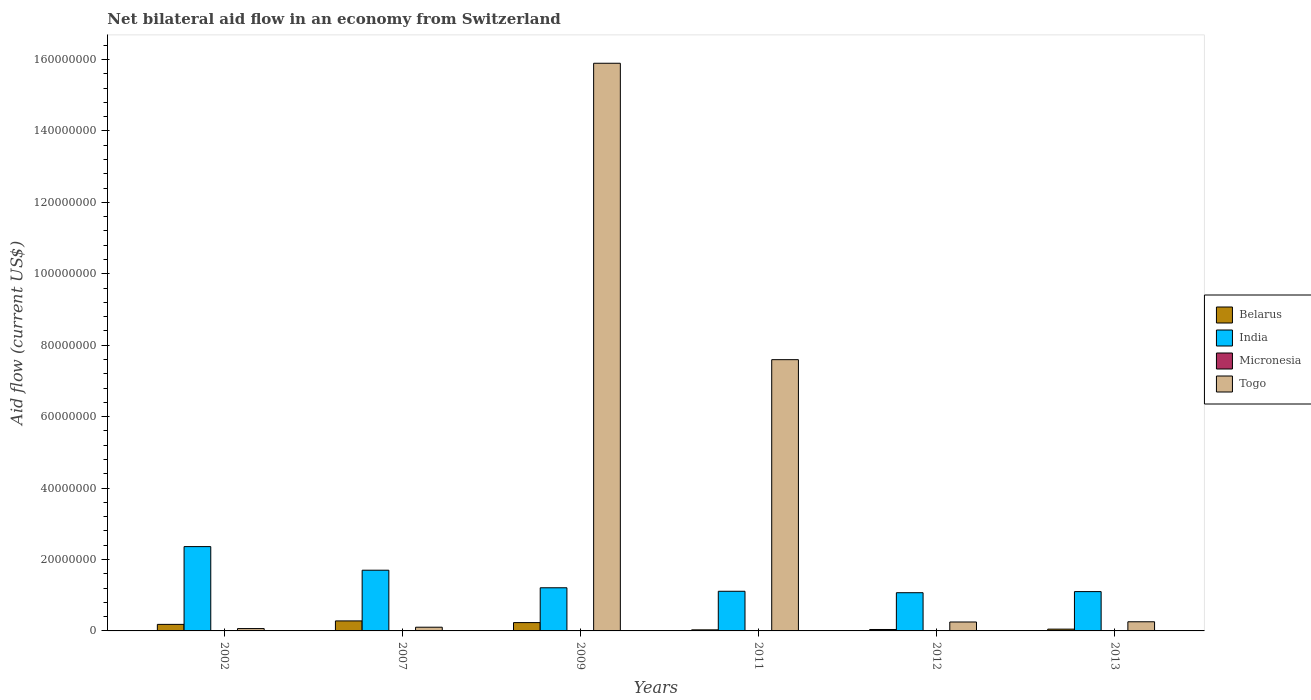How many different coloured bars are there?
Provide a succinct answer. 4. How many groups of bars are there?
Make the answer very short. 6. Are the number of bars on each tick of the X-axis equal?
Provide a succinct answer. Yes. What is the label of the 4th group of bars from the left?
Give a very brief answer. 2011. What is the net bilateral aid flow in Togo in 2007?
Ensure brevity in your answer.  1.04e+06. Across all years, what is the maximum net bilateral aid flow in Belarus?
Keep it short and to the point. 2.80e+06. In which year was the net bilateral aid flow in Togo minimum?
Your answer should be compact. 2002. What is the total net bilateral aid flow in Togo in the graph?
Make the answer very short. 2.42e+08. What is the difference between the net bilateral aid flow in Togo in 2009 and that in 2013?
Make the answer very short. 1.56e+08. What is the difference between the net bilateral aid flow in Micronesia in 2009 and the net bilateral aid flow in India in 2013?
Ensure brevity in your answer.  -1.10e+07. What is the average net bilateral aid flow in Belarus per year?
Keep it short and to the point. 1.36e+06. In the year 2007, what is the difference between the net bilateral aid flow in Micronesia and net bilateral aid flow in Belarus?
Ensure brevity in your answer.  -2.75e+06. In how many years, is the net bilateral aid flow in Belarus greater than 32000000 US$?
Provide a short and direct response. 0. What is the ratio of the net bilateral aid flow in Togo in 2002 to that in 2011?
Make the answer very short. 0.01. What is the difference between the highest and the second highest net bilateral aid flow in Togo?
Keep it short and to the point. 8.30e+07. What is the difference between the highest and the lowest net bilateral aid flow in Togo?
Ensure brevity in your answer.  1.58e+08. In how many years, is the net bilateral aid flow in India greater than the average net bilateral aid flow in India taken over all years?
Your response must be concise. 2. Is the sum of the net bilateral aid flow in Micronesia in 2002 and 2013 greater than the maximum net bilateral aid flow in Belarus across all years?
Give a very brief answer. No. What does the 3rd bar from the left in 2012 represents?
Offer a terse response. Micronesia. Are the values on the major ticks of Y-axis written in scientific E-notation?
Make the answer very short. No. Does the graph contain grids?
Offer a very short reply. No. What is the title of the graph?
Provide a succinct answer. Net bilateral aid flow in an economy from Switzerland. Does "Dominica" appear as one of the legend labels in the graph?
Offer a terse response. No. What is the label or title of the Y-axis?
Ensure brevity in your answer.  Aid flow (current US$). What is the Aid flow (current US$) in Belarus in 2002?
Give a very brief answer. 1.83e+06. What is the Aid flow (current US$) in India in 2002?
Keep it short and to the point. 2.36e+07. What is the Aid flow (current US$) of Togo in 2002?
Your answer should be very brief. 6.60e+05. What is the Aid flow (current US$) in Belarus in 2007?
Keep it short and to the point. 2.80e+06. What is the Aid flow (current US$) of India in 2007?
Keep it short and to the point. 1.70e+07. What is the Aid flow (current US$) of Micronesia in 2007?
Make the answer very short. 5.00e+04. What is the Aid flow (current US$) of Togo in 2007?
Provide a succinct answer. 1.04e+06. What is the Aid flow (current US$) in Belarus in 2009?
Offer a terse response. 2.33e+06. What is the Aid flow (current US$) in India in 2009?
Give a very brief answer. 1.21e+07. What is the Aid flow (current US$) in Togo in 2009?
Offer a terse response. 1.59e+08. What is the Aid flow (current US$) in Belarus in 2011?
Keep it short and to the point. 3.00e+05. What is the Aid flow (current US$) of India in 2011?
Make the answer very short. 1.11e+07. What is the Aid flow (current US$) of Micronesia in 2011?
Your response must be concise. 3.00e+04. What is the Aid flow (current US$) of Togo in 2011?
Your response must be concise. 7.60e+07. What is the Aid flow (current US$) of India in 2012?
Provide a succinct answer. 1.07e+07. What is the Aid flow (current US$) of Micronesia in 2012?
Your response must be concise. 2.00e+04. What is the Aid flow (current US$) of Togo in 2012?
Your response must be concise. 2.50e+06. What is the Aid flow (current US$) in India in 2013?
Offer a terse response. 1.10e+07. What is the Aid flow (current US$) of Togo in 2013?
Offer a very short reply. 2.56e+06. Across all years, what is the maximum Aid flow (current US$) in Belarus?
Offer a very short reply. 2.80e+06. Across all years, what is the maximum Aid flow (current US$) in India?
Offer a terse response. 2.36e+07. Across all years, what is the maximum Aid flow (current US$) of Togo?
Provide a succinct answer. 1.59e+08. Across all years, what is the minimum Aid flow (current US$) in India?
Provide a short and direct response. 1.07e+07. What is the total Aid flow (current US$) of Belarus in the graph?
Your answer should be very brief. 8.16e+06. What is the total Aid flow (current US$) of India in the graph?
Provide a succinct answer. 8.55e+07. What is the total Aid flow (current US$) of Togo in the graph?
Keep it short and to the point. 2.42e+08. What is the difference between the Aid flow (current US$) of Belarus in 2002 and that in 2007?
Your answer should be very brief. -9.70e+05. What is the difference between the Aid flow (current US$) of India in 2002 and that in 2007?
Your answer should be compact. 6.61e+06. What is the difference between the Aid flow (current US$) of Micronesia in 2002 and that in 2007?
Give a very brief answer. -10000. What is the difference between the Aid flow (current US$) of Togo in 2002 and that in 2007?
Keep it short and to the point. -3.80e+05. What is the difference between the Aid flow (current US$) of Belarus in 2002 and that in 2009?
Ensure brevity in your answer.  -5.00e+05. What is the difference between the Aid flow (current US$) of India in 2002 and that in 2009?
Make the answer very short. 1.15e+07. What is the difference between the Aid flow (current US$) in Micronesia in 2002 and that in 2009?
Provide a succinct answer. 10000. What is the difference between the Aid flow (current US$) of Togo in 2002 and that in 2009?
Give a very brief answer. -1.58e+08. What is the difference between the Aid flow (current US$) in Belarus in 2002 and that in 2011?
Offer a terse response. 1.53e+06. What is the difference between the Aid flow (current US$) in India in 2002 and that in 2011?
Offer a terse response. 1.25e+07. What is the difference between the Aid flow (current US$) of Togo in 2002 and that in 2011?
Offer a terse response. -7.53e+07. What is the difference between the Aid flow (current US$) in Belarus in 2002 and that in 2012?
Give a very brief answer. 1.43e+06. What is the difference between the Aid flow (current US$) in India in 2002 and that in 2012?
Your answer should be compact. 1.29e+07. What is the difference between the Aid flow (current US$) in Togo in 2002 and that in 2012?
Your response must be concise. -1.84e+06. What is the difference between the Aid flow (current US$) in Belarus in 2002 and that in 2013?
Give a very brief answer. 1.33e+06. What is the difference between the Aid flow (current US$) in India in 2002 and that in 2013?
Give a very brief answer. 1.26e+07. What is the difference between the Aid flow (current US$) of Togo in 2002 and that in 2013?
Give a very brief answer. -1.90e+06. What is the difference between the Aid flow (current US$) in Belarus in 2007 and that in 2009?
Offer a very short reply. 4.70e+05. What is the difference between the Aid flow (current US$) in India in 2007 and that in 2009?
Keep it short and to the point. 4.92e+06. What is the difference between the Aid flow (current US$) of Micronesia in 2007 and that in 2009?
Your answer should be very brief. 2.00e+04. What is the difference between the Aid flow (current US$) of Togo in 2007 and that in 2009?
Offer a terse response. -1.58e+08. What is the difference between the Aid flow (current US$) in Belarus in 2007 and that in 2011?
Your answer should be compact. 2.50e+06. What is the difference between the Aid flow (current US$) in India in 2007 and that in 2011?
Offer a terse response. 5.90e+06. What is the difference between the Aid flow (current US$) of Micronesia in 2007 and that in 2011?
Give a very brief answer. 2.00e+04. What is the difference between the Aid flow (current US$) in Togo in 2007 and that in 2011?
Provide a short and direct response. -7.49e+07. What is the difference between the Aid flow (current US$) of Belarus in 2007 and that in 2012?
Provide a short and direct response. 2.40e+06. What is the difference between the Aid flow (current US$) in India in 2007 and that in 2012?
Ensure brevity in your answer.  6.30e+06. What is the difference between the Aid flow (current US$) of Togo in 2007 and that in 2012?
Ensure brevity in your answer.  -1.46e+06. What is the difference between the Aid flow (current US$) in Belarus in 2007 and that in 2013?
Provide a short and direct response. 2.30e+06. What is the difference between the Aid flow (current US$) in India in 2007 and that in 2013?
Ensure brevity in your answer.  5.99e+06. What is the difference between the Aid flow (current US$) in Micronesia in 2007 and that in 2013?
Provide a succinct answer. 2.00e+04. What is the difference between the Aid flow (current US$) of Togo in 2007 and that in 2013?
Ensure brevity in your answer.  -1.52e+06. What is the difference between the Aid flow (current US$) of Belarus in 2009 and that in 2011?
Provide a short and direct response. 2.03e+06. What is the difference between the Aid flow (current US$) in India in 2009 and that in 2011?
Offer a terse response. 9.80e+05. What is the difference between the Aid flow (current US$) of Togo in 2009 and that in 2011?
Your answer should be compact. 8.30e+07. What is the difference between the Aid flow (current US$) of Belarus in 2009 and that in 2012?
Keep it short and to the point. 1.93e+06. What is the difference between the Aid flow (current US$) in India in 2009 and that in 2012?
Give a very brief answer. 1.38e+06. What is the difference between the Aid flow (current US$) in Micronesia in 2009 and that in 2012?
Offer a very short reply. 10000. What is the difference between the Aid flow (current US$) of Togo in 2009 and that in 2012?
Offer a terse response. 1.56e+08. What is the difference between the Aid flow (current US$) in Belarus in 2009 and that in 2013?
Provide a short and direct response. 1.83e+06. What is the difference between the Aid flow (current US$) of India in 2009 and that in 2013?
Provide a short and direct response. 1.07e+06. What is the difference between the Aid flow (current US$) of Togo in 2009 and that in 2013?
Keep it short and to the point. 1.56e+08. What is the difference between the Aid flow (current US$) of Belarus in 2011 and that in 2012?
Offer a terse response. -1.00e+05. What is the difference between the Aid flow (current US$) of India in 2011 and that in 2012?
Your response must be concise. 4.00e+05. What is the difference between the Aid flow (current US$) of Togo in 2011 and that in 2012?
Provide a succinct answer. 7.34e+07. What is the difference between the Aid flow (current US$) in Micronesia in 2011 and that in 2013?
Your answer should be compact. 0. What is the difference between the Aid flow (current US$) of Togo in 2011 and that in 2013?
Your answer should be compact. 7.34e+07. What is the difference between the Aid flow (current US$) in India in 2012 and that in 2013?
Your answer should be very brief. -3.10e+05. What is the difference between the Aid flow (current US$) of Micronesia in 2012 and that in 2013?
Provide a succinct answer. -10000. What is the difference between the Aid flow (current US$) of Belarus in 2002 and the Aid flow (current US$) of India in 2007?
Give a very brief answer. -1.52e+07. What is the difference between the Aid flow (current US$) of Belarus in 2002 and the Aid flow (current US$) of Micronesia in 2007?
Provide a short and direct response. 1.78e+06. What is the difference between the Aid flow (current US$) of Belarus in 2002 and the Aid flow (current US$) of Togo in 2007?
Ensure brevity in your answer.  7.90e+05. What is the difference between the Aid flow (current US$) of India in 2002 and the Aid flow (current US$) of Micronesia in 2007?
Make the answer very short. 2.36e+07. What is the difference between the Aid flow (current US$) in India in 2002 and the Aid flow (current US$) in Togo in 2007?
Your response must be concise. 2.26e+07. What is the difference between the Aid flow (current US$) in Belarus in 2002 and the Aid flow (current US$) in India in 2009?
Provide a short and direct response. -1.02e+07. What is the difference between the Aid flow (current US$) of Belarus in 2002 and the Aid flow (current US$) of Micronesia in 2009?
Your response must be concise. 1.80e+06. What is the difference between the Aid flow (current US$) in Belarus in 2002 and the Aid flow (current US$) in Togo in 2009?
Ensure brevity in your answer.  -1.57e+08. What is the difference between the Aid flow (current US$) of India in 2002 and the Aid flow (current US$) of Micronesia in 2009?
Your answer should be very brief. 2.36e+07. What is the difference between the Aid flow (current US$) of India in 2002 and the Aid flow (current US$) of Togo in 2009?
Ensure brevity in your answer.  -1.35e+08. What is the difference between the Aid flow (current US$) in Micronesia in 2002 and the Aid flow (current US$) in Togo in 2009?
Your answer should be compact. -1.59e+08. What is the difference between the Aid flow (current US$) of Belarus in 2002 and the Aid flow (current US$) of India in 2011?
Provide a succinct answer. -9.27e+06. What is the difference between the Aid flow (current US$) in Belarus in 2002 and the Aid flow (current US$) in Micronesia in 2011?
Your answer should be very brief. 1.80e+06. What is the difference between the Aid flow (current US$) of Belarus in 2002 and the Aid flow (current US$) of Togo in 2011?
Provide a succinct answer. -7.41e+07. What is the difference between the Aid flow (current US$) in India in 2002 and the Aid flow (current US$) in Micronesia in 2011?
Offer a very short reply. 2.36e+07. What is the difference between the Aid flow (current US$) in India in 2002 and the Aid flow (current US$) in Togo in 2011?
Provide a short and direct response. -5.23e+07. What is the difference between the Aid flow (current US$) in Micronesia in 2002 and the Aid flow (current US$) in Togo in 2011?
Ensure brevity in your answer.  -7.59e+07. What is the difference between the Aid flow (current US$) in Belarus in 2002 and the Aid flow (current US$) in India in 2012?
Provide a short and direct response. -8.87e+06. What is the difference between the Aid flow (current US$) in Belarus in 2002 and the Aid flow (current US$) in Micronesia in 2012?
Ensure brevity in your answer.  1.81e+06. What is the difference between the Aid flow (current US$) of Belarus in 2002 and the Aid flow (current US$) of Togo in 2012?
Your answer should be very brief. -6.70e+05. What is the difference between the Aid flow (current US$) of India in 2002 and the Aid flow (current US$) of Micronesia in 2012?
Your answer should be compact. 2.36e+07. What is the difference between the Aid flow (current US$) in India in 2002 and the Aid flow (current US$) in Togo in 2012?
Your response must be concise. 2.11e+07. What is the difference between the Aid flow (current US$) in Micronesia in 2002 and the Aid flow (current US$) in Togo in 2012?
Keep it short and to the point. -2.46e+06. What is the difference between the Aid flow (current US$) in Belarus in 2002 and the Aid flow (current US$) in India in 2013?
Keep it short and to the point. -9.18e+06. What is the difference between the Aid flow (current US$) in Belarus in 2002 and the Aid flow (current US$) in Micronesia in 2013?
Your answer should be compact. 1.80e+06. What is the difference between the Aid flow (current US$) in Belarus in 2002 and the Aid flow (current US$) in Togo in 2013?
Your response must be concise. -7.30e+05. What is the difference between the Aid flow (current US$) of India in 2002 and the Aid flow (current US$) of Micronesia in 2013?
Ensure brevity in your answer.  2.36e+07. What is the difference between the Aid flow (current US$) of India in 2002 and the Aid flow (current US$) of Togo in 2013?
Offer a terse response. 2.10e+07. What is the difference between the Aid flow (current US$) in Micronesia in 2002 and the Aid flow (current US$) in Togo in 2013?
Offer a terse response. -2.52e+06. What is the difference between the Aid flow (current US$) of Belarus in 2007 and the Aid flow (current US$) of India in 2009?
Your answer should be very brief. -9.28e+06. What is the difference between the Aid flow (current US$) of Belarus in 2007 and the Aid flow (current US$) of Micronesia in 2009?
Offer a terse response. 2.77e+06. What is the difference between the Aid flow (current US$) in Belarus in 2007 and the Aid flow (current US$) in Togo in 2009?
Provide a succinct answer. -1.56e+08. What is the difference between the Aid flow (current US$) of India in 2007 and the Aid flow (current US$) of Micronesia in 2009?
Make the answer very short. 1.70e+07. What is the difference between the Aid flow (current US$) in India in 2007 and the Aid flow (current US$) in Togo in 2009?
Offer a terse response. -1.42e+08. What is the difference between the Aid flow (current US$) of Micronesia in 2007 and the Aid flow (current US$) of Togo in 2009?
Offer a terse response. -1.59e+08. What is the difference between the Aid flow (current US$) in Belarus in 2007 and the Aid flow (current US$) in India in 2011?
Ensure brevity in your answer.  -8.30e+06. What is the difference between the Aid flow (current US$) of Belarus in 2007 and the Aid flow (current US$) of Micronesia in 2011?
Provide a short and direct response. 2.77e+06. What is the difference between the Aid flow (current US$) of Belarus in 2007 and the Aid flow (current US$) of Togo in 2011?
Give a very brief answer. -7.32e+07. What is the difference between the Aid flow (current US$) of India in 2007 and the Aid flow (current US$) of Micronesia in 2011?
Keep it short and to the point. 1.70e+07. What is the difference between the Aid flow (current US$) of India in 2007 and the Aid flow (current US$) of Togo in 2011?
Make the answer very short. -5.90e+07. What is the difference between the Aid flow (current US$) of Micronesia in 2007 and the Aid flow (current US$) of Togo in 2011?
Offer a very short reply. -7.59e+07. What is the difference between the Aid flow (current US$) of Belarus in 2007 and the Aid flow (current US$) of India in 2012?
Offer a very short reply. -7.90e+06. What is the difference between the Aid flow (current US$) in Belarus in 2007 and the Aid flow (current US$) in Micronesia in 2012?
Make the answer very short. 2.78e+06. What is the difference between the Aid flow (current US$) of India in 2007 and the Aid flow (current US$) of Micronesia in 2012?
Your answer should be compact. 1.70e+07. What is the difference between the Aid flow (current US$) of India in 2007 and the Aid flow (current US$) of Togo in 2012?
Provide a succinct answer. 1.45e+07. What is the difference between the Aid flow (current US$) in Micronesia in 2007 and the Aid flow (current US$) in Togo in 2012?
Offer a very short reply. -2.45e+06. What is the difference between the Aid flow (current US$) of Belarus in 2007 and the Aid flow (current US$) of India in 2013?
Your response must be concise. -8.21e+06. What is the difference between the Aid flow (current US$) of Belarus in 2007 and the Aid flow (current US$) of Micronesia in 2013?
Keep it short and to the point. 2.77e+06. What is the difference between the Aid flow (current US$) of India in 2007 and the Aid flow (current US$) of Micronesia in 2013?
Make the answer very short. 1.70e+07. What is the difference between the Aid flow (current US$) in India in 2007 and the Aid flow (current US$) in Togo in 2013?
Ensure brevity in your answer.  1.44e+07. What is the difference between the Aid flow (current US$) in Micronesia in 2007 and the Aid flow (current US$) in Togo in 2013?
Offer a very short reply. -2.51e+06. What is the difference between the Aid flow (current US$) of Belarus in 2009 and the Aid flow (current US$) of India in 2011?
Give a very brief answer. -8.77e+06. What is the difference between the Aid flow (current US$) in Belarus in 2009 and the Aid flow (current US$) in Micronesia in 2011?
Offer a terse response. 2.30e+06. What is the difference between the Aid flow (current US$) of Belarus in 2009 and the Aid flow (current US$) of Togo in 2011?
Provide a short and direct response. -7.36e+07. What is the difference between the Aid flow (current US$) of India in 2009 and the Aid flow (current US$) of Micronesia in 2011?
Offer a very short reply. 1.20e+07. What is the difference between the Aid flow (current US$) of India in 2009 and the Aid flow (current US$) of Togo in 2011?
Your answer should be compact. -6.39e+07. What is the difference between the Aid flow (current US$) in Micronesia in 2009 and the Aid flow (current US$) in Togo in 2011?
Provide a short and direct response. -7.59e+07. What is the difference between the Aid flow (current US$) of Belarus in 2009 and the Aid flow (current US$) of India in 2012?
Give a very brief answer. -8.37e+06. What is the difference between the Aid flow (current US$) of Belarus in 2009 and the Aid flow (current US$) of Micronesia in 2012?
Your answer should be compact. 2.31e+06. What is the difference between the Aid flow (current US$) of India in 2009 and the Aid flow (current US$) of Micronesia in 2012?
Your answer should be very brief. 1.21e+07. What is the difference between the Aid flow (current US$) in India in 2009 and the Aid flow (current US$) in Togo in 2012?
Provide a succinct answer. 9.58e+06. What is the difference between the Aid flow (current US$) in Micronesia in 2009 and the Aid flow (current US$) in Togo in 2012?
Your answer should be very brief. -2.47e+06. What is the difference between the Aid flow (current US$) in Belarus in 2009 and the Aid flow (current US$) in India in 2013?
Provide a succinct answer. -8.68e+06. What is the difference between the Aid flow (current US$) of Belarus in 2009 and the Aid flow (current US$) of Micronesia in 2013?
Offer a very short reply. 2.30e+06. What is the difference between the Aid flow (current US$) of Belarus in 2009 and the Aid flow (current US$) of Togo in 2013?
Give a very brief answer. -2.30e+05. What is the difference between the Aid flow (current US$) in India in 2009 and the Aid flow (current US$) in Micronesia in 2013?
Your answer should be very brief. 1.20e+07. What is the difference between the Aid flow (current US$) in India in 2009 and the Aid flow (current US$) in Togo in 2013?
Make the answer very short. 9.52e+06. What is the difference between the Aid flow (current US$) of Micronesia in 2009 and the Aid flow (current US$) of Togo in 2013?
Make the answer very short. -2.53e+06. What is the difference between the Aid flow (current US$) in Belarus in 2011 and the Aid flow (current US$) in India in 2012?
Your response must be concise. -1.04e+07. What is the difference between the Aid flow (current US$) in Belarus in 2011 and the Aid flow (current US$) in Micronesia in 2012?
Keep it short and to the point. 2.80e+05. What is the difference between the Aid flow (current US$) of Belarus in 2011 and the Aid flow (current US$) of Togo in 2012?
Your answer should be compact. -2.20e+06. What is the difference between the Aid flow (current US$) in India in 2011 and the Aid flow (current US$) in Micronesia in 2012?
Provide a succinct answer. 1.11e+07. What is the difference between the Aid flow (current US$) in India in 2011 and the Aid flow (current US$) in Togo in 2012?
Give a very brief answer. 8.60e+06. What is the difference between the Aid flow (current US$) in Micronesia in 2011 and the Aid flow (current US$) in Togo in 2012?
Keep it short and to the point. -2.47e+06. What is the difference between the Aid flow (current US$) of Belarus in 2011 and the Aid flow (current US$) of India in 2013?
Offer a very short reply. -1.07e+07. What is the difference between the Aid flow (current US$) of Belarus in 2011 and the Aid flow (current US$) of Togo in 2013?
Make the answer very short. -2.26e+06. What is the difference between the Aid flow (current US$) in India in 2011 and the Aid flow (current US$) in Micronesia in 2013?
Your answer should be compact. 1.11e+07. What is the difference between the Aid flow (current US$) of India in 2011 and the Aid flow (current US$) of Togo in 2013?
Offer a very short reply. 8.54e+06. What is the difference between the Aid flow (current US$) in Micronesia in 2011 and the Aid flow (current US$) in Togo in 2013?
Your answer should be very brief. -2.53e+06. What is the difference between the Aid flow (current US$) of Belarus in 2012 and the Aid flow (current US$) of India in 2013?
Your response must be concise. -1.06e+07. What is the difference between the Aid flow (current US$) of Belarus in 2012 and the Aid flow (current US$) of Togo in 2013?
Ensure brevity in your answer.  -2.16e+06. What is the difference between the Aid flow (current US$) of India in 2012 and the Aid flow (current US$) of Micronesia in 2013?
Offer a very short reply. 1.07e+07. What is the difference between the Aid flow (current US$) in India in 2012 and the Aid flow (current US$) in Togo in 2013?
Your answer should be compact. 8.14e+06. What is the difference between the Aid flow (current US$) in Micronesia in 2012 and the Aid flow (current US$) in Togo in 2013?
Provide a short and direct response. -2.54e+06. What is the average Aid flow (current US$) in Belarus per year?
Provide a succinct answer. 1.36e+06. What is the average Aid flow (current US$) in India per year?
Give a very brief answer. 1.42e+07. What is the average Aid flow (current US$) in Micronesia per year?
Your response must be concise. 3.33e+04. What is the average Aid flow (current US$) of Togo per year?
Offer a very short reply. 4.03e+07. In the year 2002, what is the difference between the Aid flow (current US$) of Belarus and Aid flow (current US$) of India?
Provide a succinct answer. -2.18e+07. In the year 2002, what is the difference between the Aid flow (current US$) in Belarus and Aid flow (current US$) in Micronesia?
Offer a very short reply. 1.79e+06. In the year 2002, what is the difference between the Aid flow (current US$) in Belarus and Aid flow (current US$) in Togo?
Provide a succinct answer. 1.17e+06. In the year 2002, what is the difference between the Aid flow (current US$) in India and Aid flow (current US$) in Micronesia?
Your answer should be compact. 2.36e+07. In the year 2002, what is the difference between the Aid flow (current US$) in India and Aid flow (current US$) in Togo?
Give a very brief answer. 2.30e+07. In the year 2002, what is the difference between the Aid flow (current US$) of Micronesia and Aid flow (current US$) of Togo?
Your response must be concise. -6.20e+05. In the year 2007, what is the difference between the Aid flow (current US$) of Belarus and Aid flow (current US$) of India?
Your answer should be very brief. -1.42e+07. In the year 2007, what is the difference between the Aid flow (current US$) in Belarus and Aid flow (current US$) in Micronesia?
Keep it short and to the point. 2.75e+06. In the year 2007, what is the difference between the Aid flow (current US$) in Belarus and Aid flow (current US$) in Togo?
Offer a very short reply. 1.76e+06. In the year 2007, what is the difference between the Aid flow (current US$) of India and Aid flow (current US$) of Micronesia?
Provide a short and direct response. 1.70e+07. In the year 2007, what is the difference between the Aid flow (current US$) of India and Aid flow (current US$) of Togo?
Your response must be concise. 1.60e+07. In the year 2007, what is the difference between the Aid flow (current US$) of Micronesia and Aid flow (current US$) of Togo?
Your answer should be compact. -9.90e+05. In the year 2009, what is the difference between the Aid flow (current US$) of Belarus and Aid flow (current US$) of India?
Provide a succinct answer. -9.75e+06. In the year 2009, what is the difference between the Aid flow (current US$) in Belarus and Aid flow (current US$) in Micronesia?
Provide a succinct answer. 2.30e+06. In the year 2009, what is the difference between the Aid flow (current US$) of Belarus and Aid flow (current US$) of Togo?
Offer a very short reply. -1.57e+08. In the year 2009, what is the difference between the Aid flow (current US$) of India and Aid flow (current US$) of Micronesia?
Keep it short and to the point. 1.20e+07. In the year 2009, what is the difference between the Aid flow (current US$) in India and Aid flow (current US$) in Togo?
Give a very brief answer. -1.47e+08. In the year 2009, what is the difference between the Aid flow (current US$) in Micronesia and Aid flow (current US$) in Togo?
Keep it short and to the point. -1.59e+08. In the year 2011, what is the difference between the Aid flow (current US$) of Belarus and Aid flow (current US$) of India?
Keep it short and to the point. -1.08e+07. In the year 2011, what is the difference between the Aid flow (current US$) of Belarus and Aid flow (current US$) of Micronesia?
Offer a very short reply. 2.70e+05. In the year 2011, what is the difference between the Aid flow (current US$) in Belarus and Aid flow (current US$) in Togo?
Give a very brief answer. -7.56e+07. In the year 2011, what is the difference between the Aid flow (current US$) in India and Aid flow (current US$) in Micronesia?
Offer a terse response. 1.11e+07. In the year 2011, what is the difference between the Aid flow (current US$) of India and Aid flow (current US$) of Togo?
Provide a short and direct response. -6.48e+07. In the year 2011, what is the difference between the Aid flow (current US$) in Micronesia and Aid flow (current US$) in Togo?
Your answer should be compact. -7.59e+07. In the year 2012, what is the difference between the Aid flow (current US$) of Belarus and Aid flow (current US$) of India?
Provide a short and direct response. -1.03e+07. In the year 2012, what is the difference between the Aid flow (current US$) in Belarus and Aid flow (current US$) in Togo?
Provide a succinct answer. -2.10e+06. In the year 2012, what is the difference between the Aid flow (current US$) in India and Aid flow (current US$) in Micronesia?
Ensure brevity in your answer.  1.07e+07. In the year 2012, what is the difference between the Aid flow (current US$) of India and Aid flow (current US$) of Togo?
Offer a very short reply. 8.20e+06. In the year 2012, what is the difference between the Aid flow (current US$) of Micronesia and Aid flow (current US$) of Togo?
Provide a succinct answer. -2.48e+06. In the year 2013, what is the difference between the Aid flow (current US$) of Belarus and Aid flow (current US$) of India?
Give a very brief answer. -1.05e+07. In the year 2013, what is the difference between the Aid flow (current US$) of Belarus and Aid flow (current US$) of Togo?
Your answer should be compact. -2.06e+06. In the year 2013, what is the difference between the Aid flow (current US$) in India and Aid flow (current US$) in Micronesia?
Your answer should be compact. 1.10e+07. In the year 2013, what is the difference between the Aid flow (current US$) of India and Aid flow (current US$) of Togo?
Offer a very short reply. 8.45e+06. In the year 2013, what is the difference between the Aid flow (current US$) in Micronesia and Aid flow (current US$) in Togo?
Your response must be concise. -2.53e+06. What is the ratio of the Aid flow (current US$) in Belarus in 2002 to that in 2007?
Your response must be concise. 0.65. What is the ratio of the Aid flow (current US$) of India in 2002 to that in 2007?
Your answer should be very brief. 1.39. What is the ratio of the Aid flow (current US$) of Togo in 2002 to that in 2007?
Provide a short and direct response. 0.63. What is the ratio of the Aid flow (current US$) in Belarus in 2002 to that in 2009?
Keep it short and to the point. 0.79. What is the ratio of the Aid flow (current US$) of India in 2002 to that in 2009?
Your answer should be very brief. 1.95. What is the ratio of the Aid flow (current US$) in Togo in 2002 to that in 2009?
Give a very brief answer. 0. What is the ratio of the Aid flow (current US$) in India in 2002 to that in 2011?
Provide a succinct answer. 2.13. What is the ratio of the Aid flow (current US$) in Togo in 2002 to that in 2011?
Make the answer very short. 0.01. What is the ratio of the Aid flow (current US$) of Belarus in 2002 to that in 2012?
Ensure brevity in your answer.  4.58. What is the ratio of the Aid flow (current US$) of India in 2002 to that in 2012?
Provide a succinct answer. 2.21. What is the ratio of the Aid flow (current US$) in Micronesia in 2002 to that in 2012?
Make the answer very short. 2. What is the ratio of the Aid flow (current US$) of Togo in 2002 to that in 2012?
Provide a short and direct response. 0.26. What is the ratio of the Aid flow (current US$) in Belarus in 2002 to that in 2013?
Offer a very short reply. 3.66. What is the ratio of the Aid flow (current US$) in India in 2002 to that in 2013?
Provide a short and direct response. 2.14. What is the ratio of the Aid flow (current US$) of Micronesia in 2002 to that in 2013?
Give a very brief answer. 1.33. What is the ratio of the Aid flow (current US$) in Togo in 2002 to that in 2013?
Offer a terse response. 0.26. What is the ratio of the Aid flow (current US$) in Belarus in 2007 to that in 2009?
Provide a succinct answer. 1.2. What is the ratio of the Aid flow (current US$) in India in 2007 to that in 2009?
Give a very brief answer. 1.41. What is the ratio of the Aid flow (current US$) in Micronesia in 2007 to that in 2009?
Offer a very short reply. 1.67. What is the ratio of the Aid flow (current US$) in Togo in 2007 to that in 2009?
Your answer should be very brief. 0.01. What is the ratio of the Aid flow (current US$) of Belarus in 2007 to that in 2011?
Ensure brevity in your answer.  9.33. What is the ratio of the Aid flow (current US$) in India in 2007 to that in 2011?
Offer a very short reply. 1.53. What is the ratio of the Aid flow (current US$) of Micronesia in 2007 to that in 2011?
Offer a very short reply. 1.67. What is the ratio of the Aid flow (current US$) of Togo in 2007 to that in 2011?
Make the answer very short. 0.01. What is the ratio of the Aid flow (current US$) in India in 2007 to that in 2012?
Your answer should be compact. 1.59. What is the ratio of the Aid flow (current US$) in Micronesia in 2007 to that in 2012?
Your answer should be compact. 2.5. What is the ratio of the Aid flow (current US$) of Togo in 2007 to that in 2012?
Your response must be concise. 0.42. What is the ratio of the Aid flow (current US$) in India in 2007 to that in 2013?
Ensure brevity in your answer.  1.54. What is the ratio of the Aid flow (current US$) of Togo in 2007 to that in 2013?
Provide a short and direct response. 0.41. What is the ratio of the Aid flow (current US$) in Belarus in 2009 to that in 2011?
Make the answer very short. 7.77. What is the ratio of the Aid flow (current US$) of India in 2009 to that in 2011?
Your response must be concise. 1.09. What is the ratio of the Aid flow (current US$) in Togo in 2009 to that in 2011?
Your response must be concise. 2.09. What is the ratio of the Aid flow (current US$) in Belarus in 2009 to that in 2012?
Provide a succinct answer. 5.83. What is the ratio of the Aid flow (current US$) of India in 2009 to that in 2012?
Your response must be concise. 1.13. What is the ratio of the Aid flow (current US$) of Togo in 2009 to that in 2012?
Make the answer very short. 63.58. What is the ratio of the Aid flow (current US$) of Belarus in 2009 to that in 2013?
Ensure brevity in your answer.  4.66. What is the ratio of the Aid flow (current US$) in India in 2009 to that in 2013?
Give a very brief answer. 1.1. What is the ratio of the Aid flow (current US$) of Micronesia in 2009 to that in 2013?
Your response must be concise. 1. What is the ratio of the Aid flow (current US$) of Togo in 2009 to that in 2013?
Your answer should be compact. 62.09. What is the ratio of the Aid flow (current US$) of India in 2011 to that in 2012?
Your answer should be compact. 1.04. What is the ratio of the Aid flow (current US$) of Micronesia in 2011 to that in 2012?
Provide a succinct answer. 1.5. What is the ratio of the Aid flow (current US$) of Togo in 2011 to that in 2012?
Offer a terse response. 30.38. What is the ratio of the Aid flow (current US$) in Belarus in 2011 to that in 2013?
Ensure brevity in your answer.  0.6. What is the ratio of the Aid flow (current US$) in India in 2011 to that in 2013?
Keep it short and to the point. 1.01. What is the ratio of the Aid flow (current US$) of Micronesia in 2011 to that in 2013?
Your answer should be compact. 1. What is the ratio of the Aid flow (current US$) of Togo in 2011 to that in 2013?
Offer a terse response. 29.67. What is the ratio of the Aid flow (current US$) in Belarus in 2012 to that in 2013?
Make the answer very short. 0.8. What is the ratio of the Aid flow (current US$) of India in 2012 to that in 2013?
Make the answer very short. 0.97. What is the ratio of the Aid flow (current US$) in Togo in 2012 to that in 2013?
Provide a short and direct response. 0.98. What is the difference between the highest and the second highest Aid flow (current US$) in India?
Your answer should be compact. 6.61e+06. What is the difference between the highest and the second highest Aid flow (current US$) in Togo?
Your answer should be compact. 8.30e+07. What is the difference between the highest and the lowest Aid flow (current US$) in Belarus?
Provide a short and direct response. 2.50e+06. What is the difference between the highest and the lowest Aid flow (current US$) of India?
Offer a terse response. 1.29e+07. What is the difference between the highest and the lowest Aid flow (current US$) of Micronesia?
Ensure brevity in your answer.  3.00e+04. What is the difference between the highest and the lowest Aid flow (current US$) of Togo?
Your answer should be very brief. 1.58e+08. 